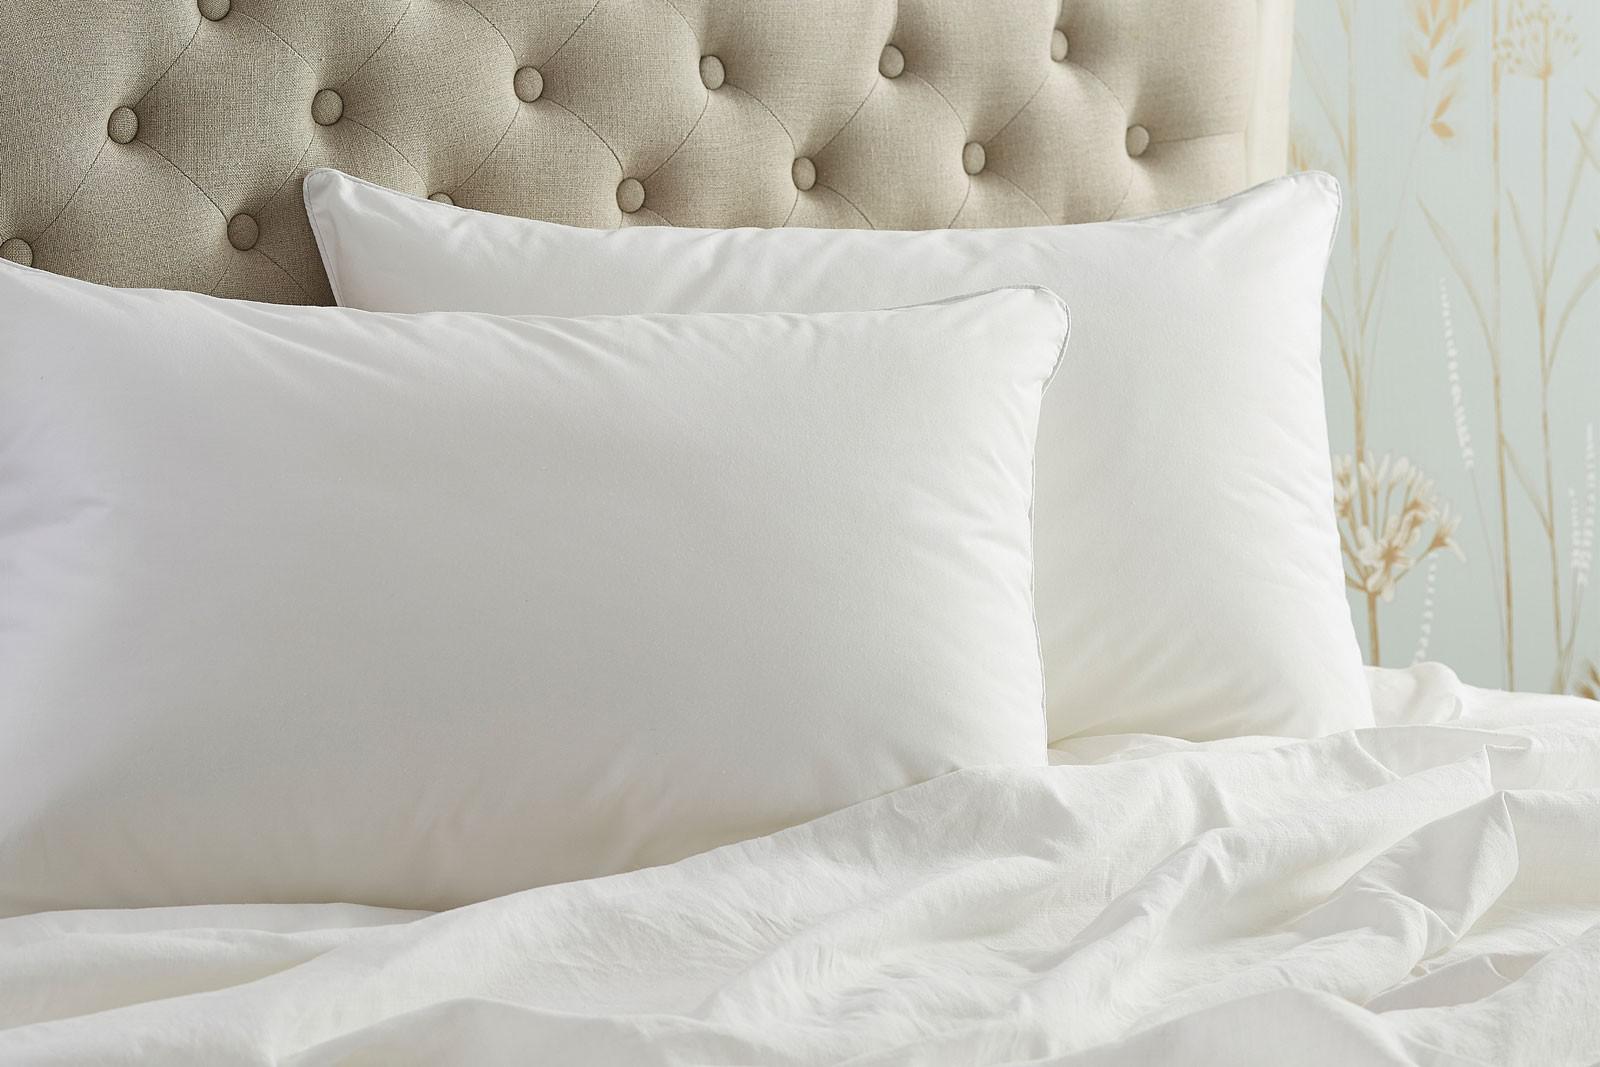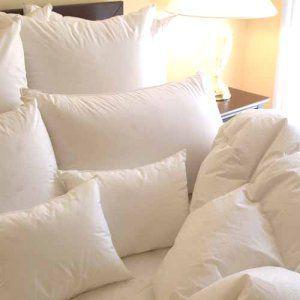The first image is the image on the left, the second image is the image on the right. Assess this claim about the two images: "The headboard in the image on the left is upholstered.". Correct or not? Answer yes or no. Yes. 